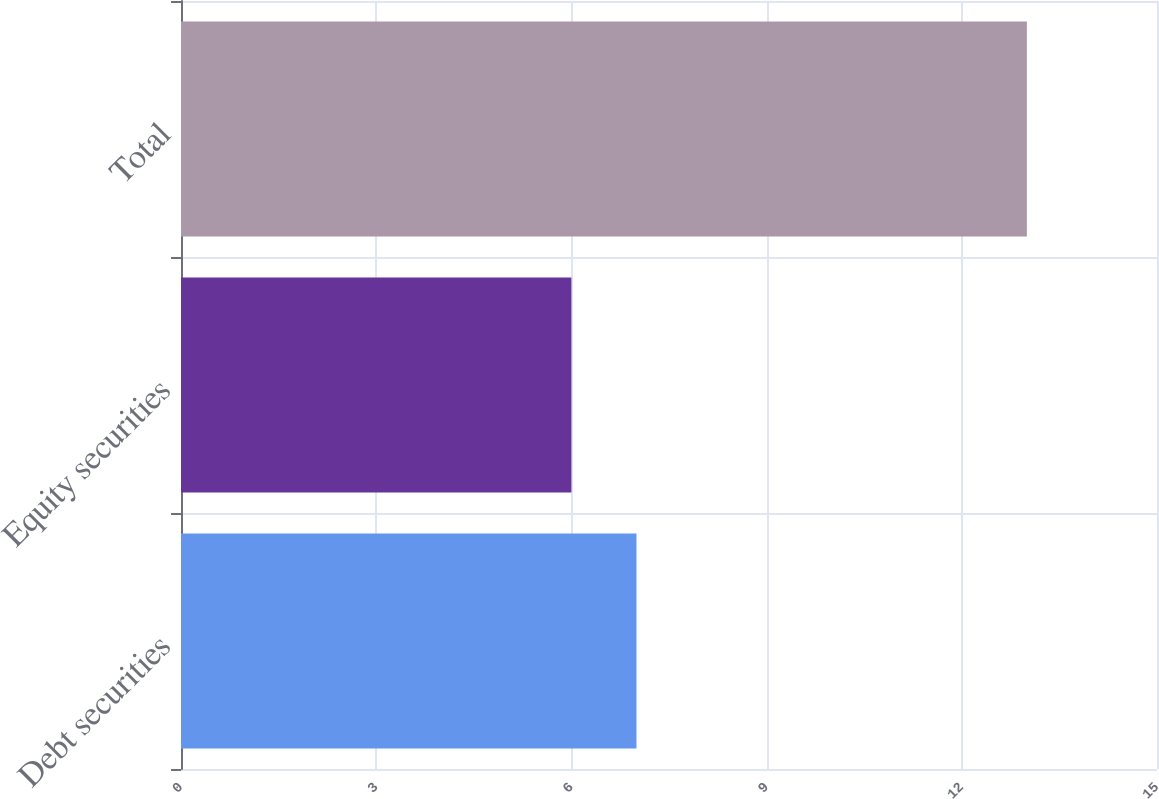Convert chart. <chart><loc_0><loc_0><loc_500><loc_500><bar_chart><fcel>Debt securities<fcel>Equity securities<fcel>Total<nl><fcel>7<fcel>6<fcel>13<nl></chart> 